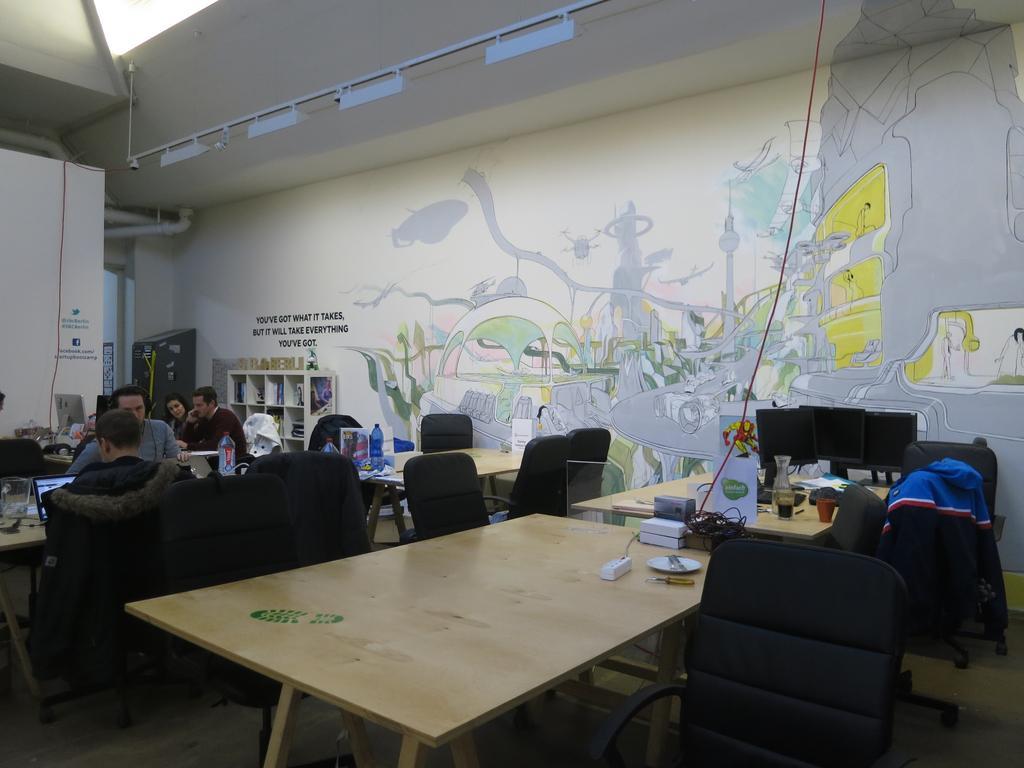How would you summarize this image in a sentence or two? In this image I can see few people are sitting on chairs. I can also see few more chairs and tables. On this table I can see few monitors. 